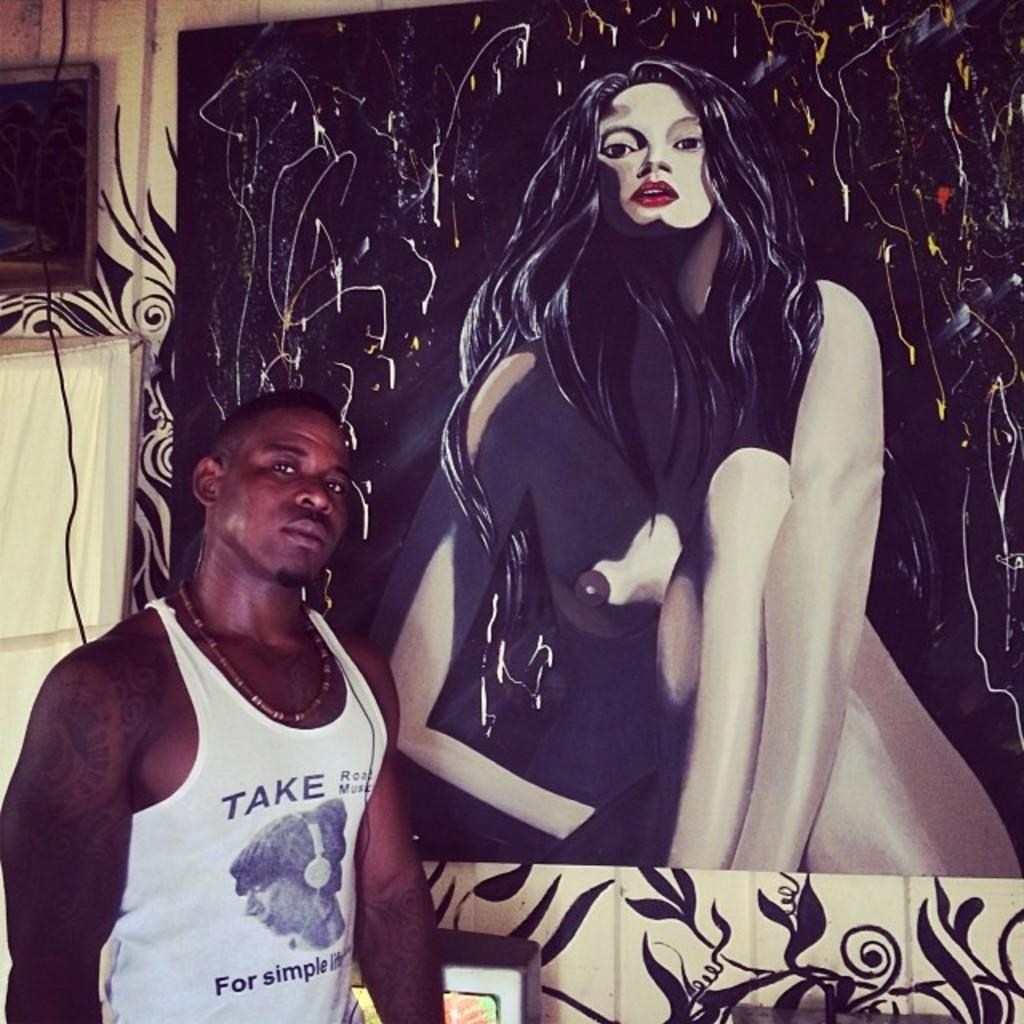Provide a one-sentence caption for the provided image. A man is posing next to a painting of a woman. 